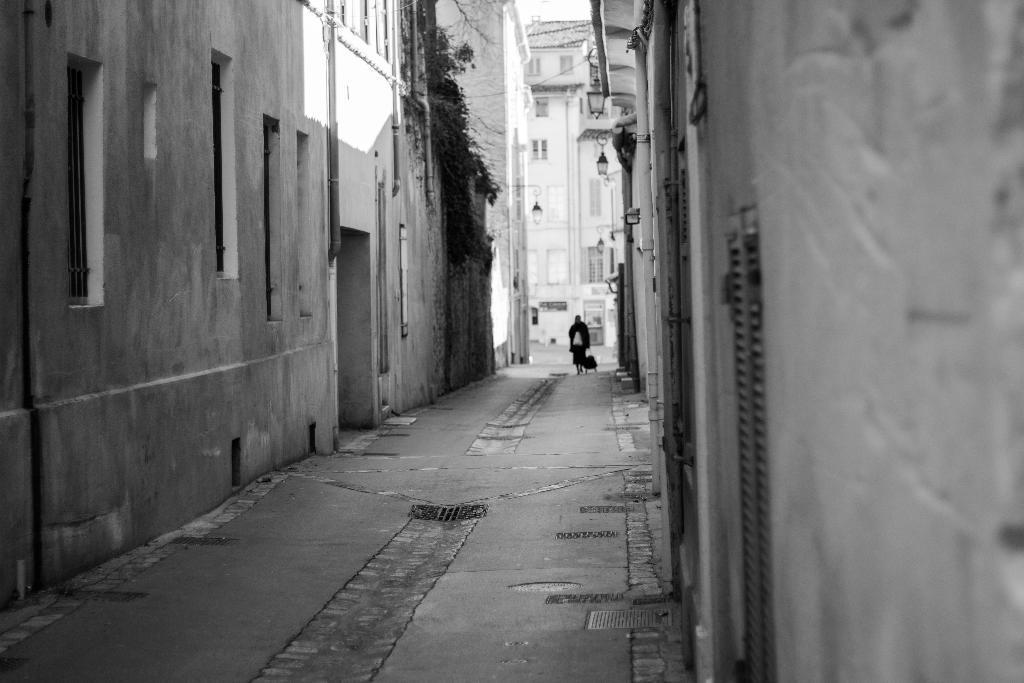Describe this image in one or two sentences. This image consists of a road. In the front, there is a person walking along with a dog. To the left and right, there are buildings along with windows. In the front, there is a small tree to the building. 